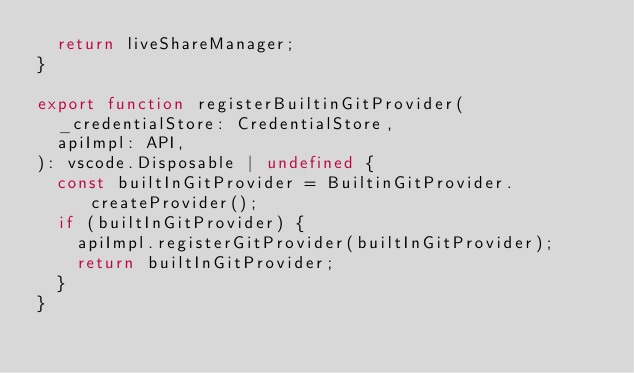Convert code to text. <code><loc_0><loc_0><loc_500><loc_500><_TypeScript_>	return liveShareManager;
}

export function registerBuiltinGitProvider(
	_credentialStore: CredentialStore,
	apiImpl: API,
): vscode.Disposable | undefined {
	const builtInGitProvider = BuiltinGitProvider.createProvider();
	if (builtInGitProvider) {
		apiImpl.registerGitProvider(builtInGitProvider);
		return builtInGitProvider;
	}
}
</code> 